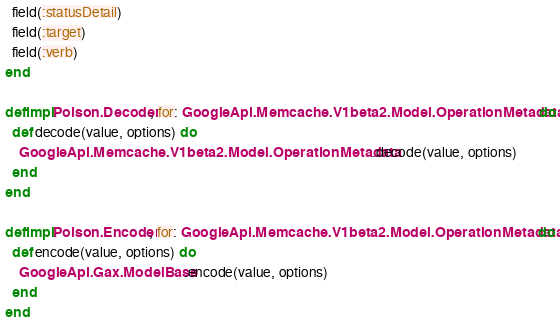Convert code to text. <code><loc_0><loc_0><loc_500><loc_500><_Elixir_>  field(:statusDetail)
  field(:target)
  field(:verb)
end

defimpl Poison.Decoder, for: GoogleApi.Memcache.V1beta2.Model.OperationMetadata do
  def decode(value, options) do
    GoogleApi.Memcache.V1beta2.Model.OperationMetadata.decode(value, options)
  end
end

defimpl Poison.Encoder, for: GoogleApi.Memcache.V1beta2.Model.OperationMetadata do
  def encode(value, options) do
    GoogleApi.Gax.ModelBase.encode(value, options)
  end
end
</code> 